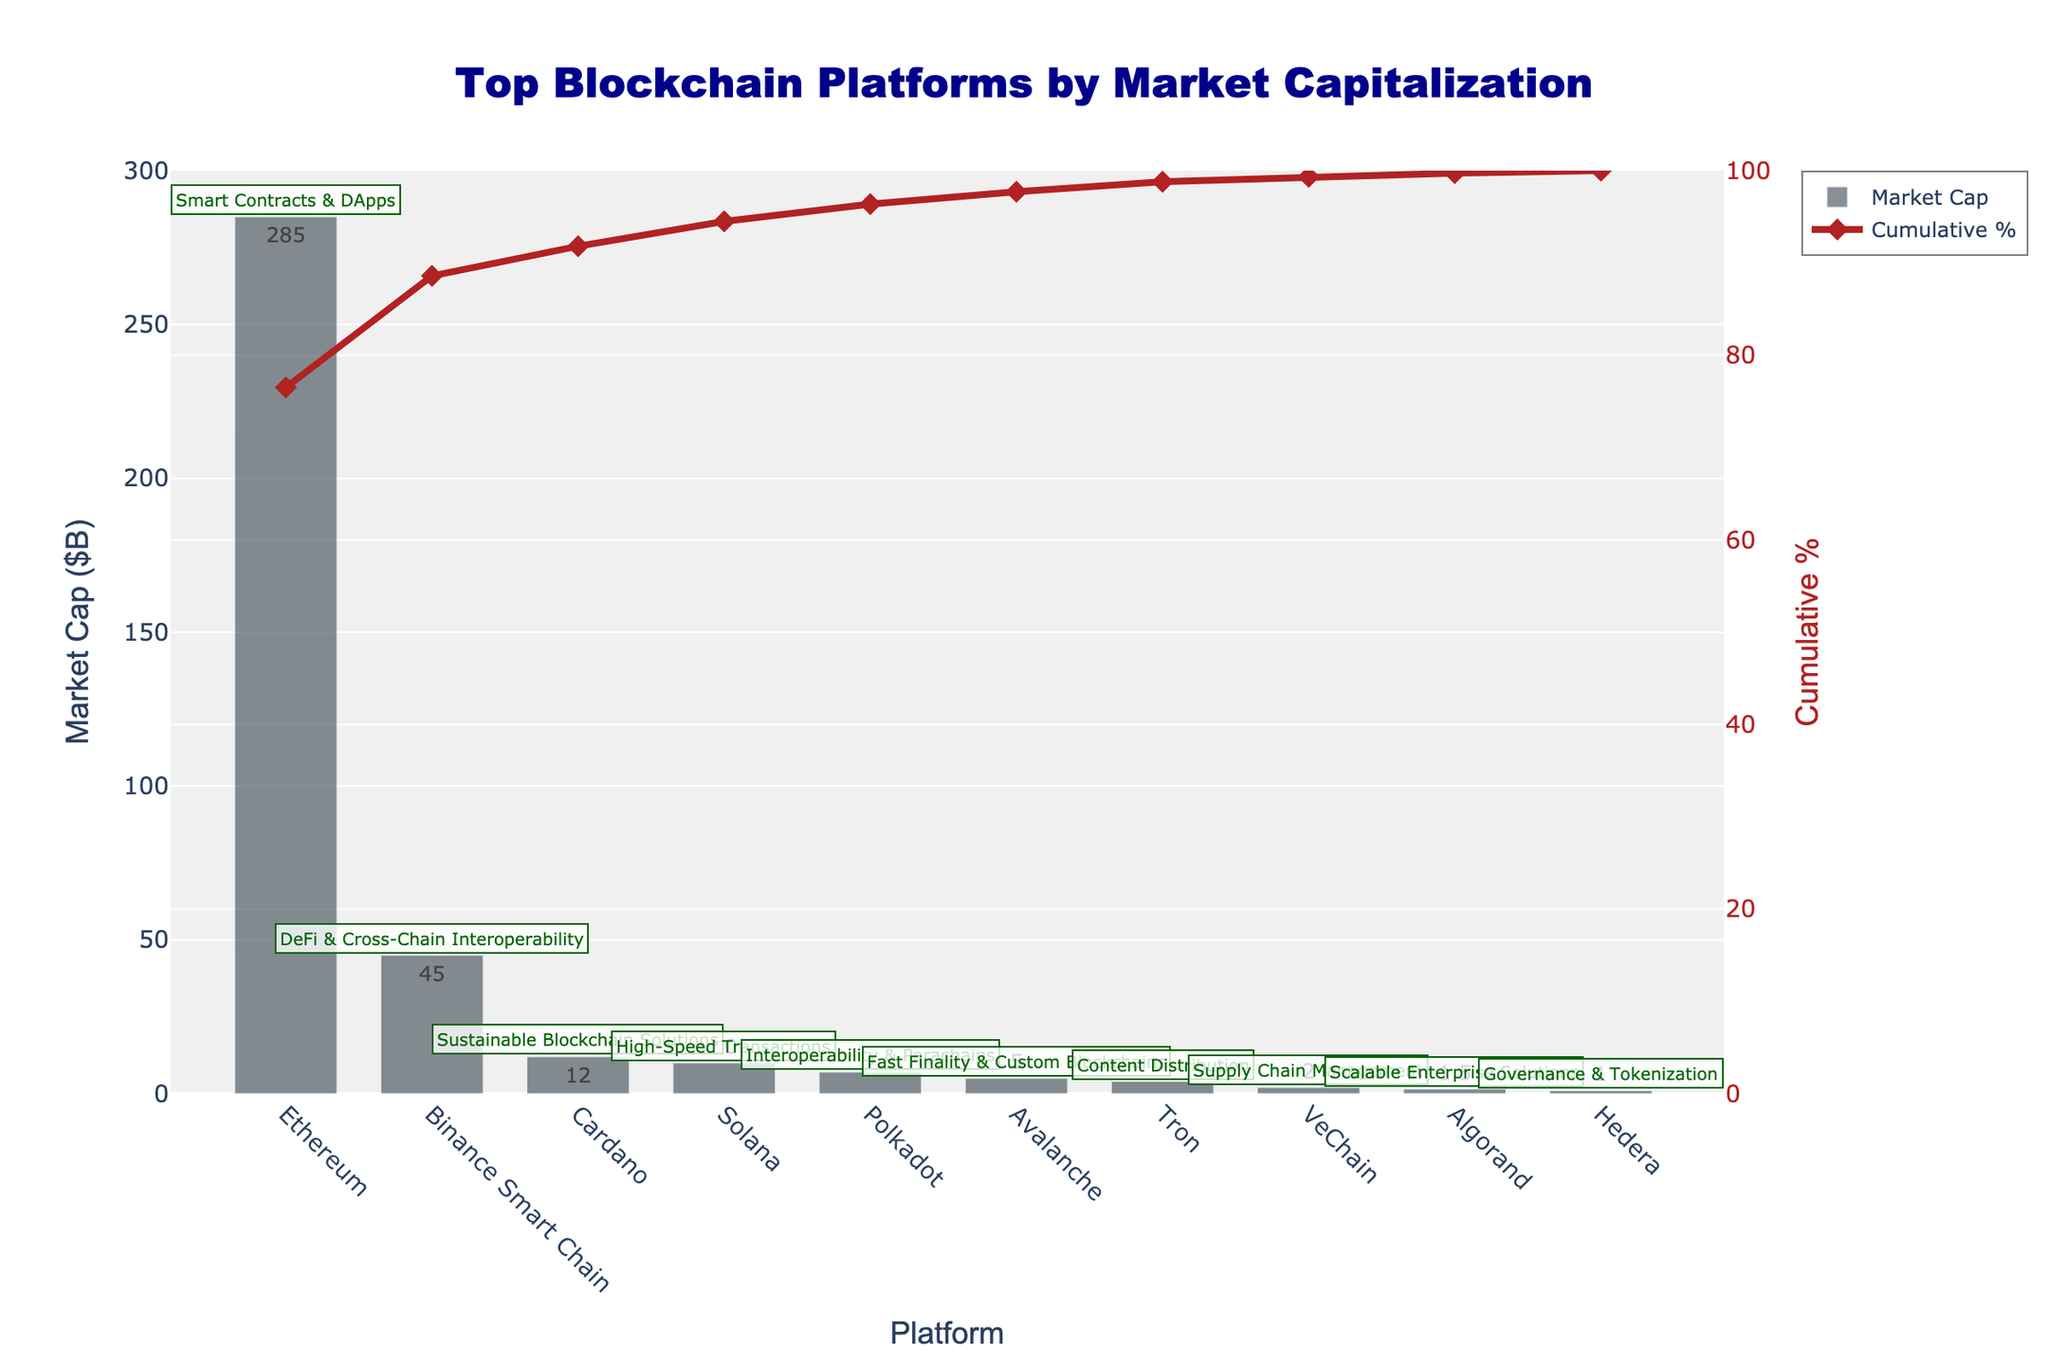What is the title of the figure? The title is located at the top center of the figure. It reads, "Top Blockchain Platforms by Market Capitalization."
Answer: Top Blockchain Platforms by Market Capitalization What platform has the highest market capitalization? By looking at the heights of the bars, Ethereum has the highest market capitalization, as indicated by the tallest bar.
Answer: Ethereum What is the primary use case of the platform with the smallest market capitalization? The smallest market cap is represented by the shortest bar, which belongs to Hedera. The annotation above Hedera shows its primary use case as "Governance & Tokenization."
Answer: Governance & Tokenization How much larger is Ethereum's market cap compared to Solana's? Ethereum's market cap is 285 billion, and Solana's is 10 billion. Subtracting these values, 285 - 10 equals 275 billion.
Answer: 275 billion Which three platforms contribute to more than half of the total market capitalization? To find platforms contributing to more than 50% market cap, look at the cumulative % line. Ethereum, Binance Smart Chain, and Cardano together surpass the 50% mark.
Answer: Ethereum, Binance Smart Chain, Cardano What is the cumulative market cap percentage after the top 5 platforms? The cumulative % after the top 5 platforms (Ethereum, Binance Smart Chain, Cardano, Solana, Polkadot) meets just over 90% based on the cumulative % line.
Answer: Just over 90% Which platform's bar height is closest to the midpoint between the highest and lowest market caps? The midpoint between the highest (285 billion) and lowest (1 billion) is (285 + 1)/2 = 143 billion. Binance Smart Chain, with a market cap of 45 billion, is the nearest in terms of proportional visualization.
Answer: Binance Smart Chain What is the primary use case for the platform with a market cap of 2 billion? Identifying the bar corresponding to 2 billion, the primary use case annotation shows that VeChain is for "Supply Chain Management."
Answer: Supply Chain Management 